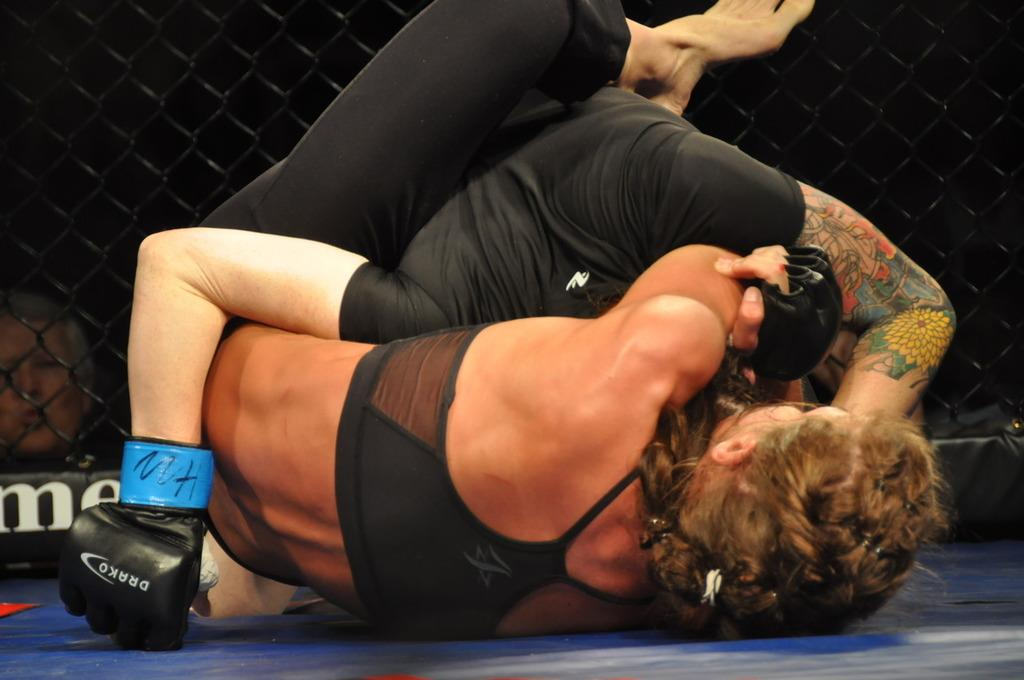<image>
Give a short and clear explanation of the subsequent image. A person wearing Drako gloves wrestles with another. 